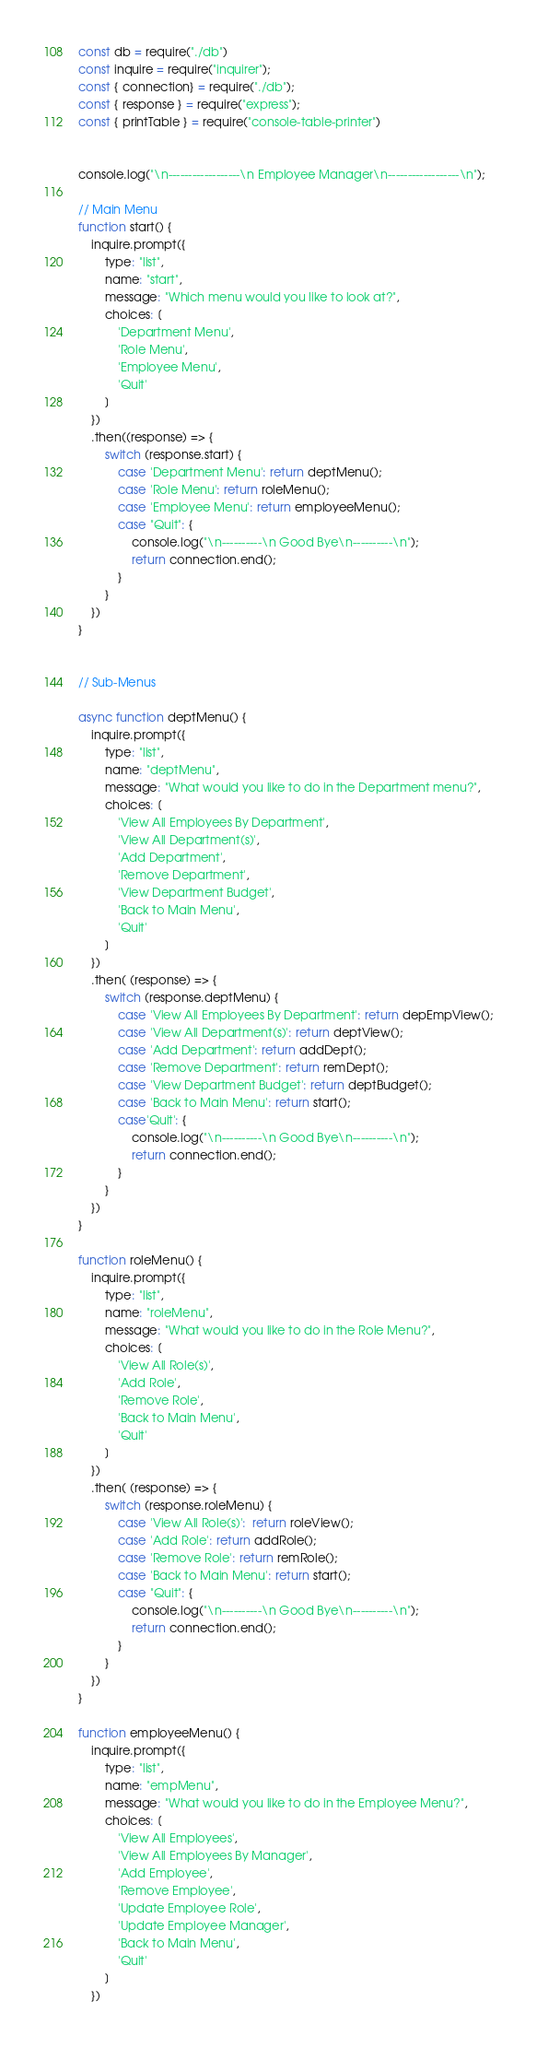<code> <loc_0><loc_0><loc_500><loc_500><_JavaScript_>const db = require("./db")
const inquire = require("inquirer");
const { connection} = require("./db");
const { response } = require("express");
const { printTable } = require("console-table-printer")


console.log("\n------------------\n Employee Manager\n------------------\n");

// Main Menu
function start() {
    inquire.prompt({
        type: "list",
        name: "start",
        message: "Which menu would you like to look at?",
        choices: [
            'Department Menu',
            'Role Menu',
            'Employee Menu',
            'Quit'
        ]
    })
    .then((response) => {
        switch (response.start) {
            case 'Department Menu': return deptMenu();
            case 'Role Menu': return roleMenu();
            case 'Employee Menu': return employeeMenu();
            case "Quit": {
                console.log("\n----------\n Good Bye\n----------\n");
                return connection.end();
            }
        }
    })
}


// Sub-Menus

async function deptMenu() {
    inquire.prompt({
        type: "list",
        name: "deptMenu",
        message: "What would you like to do in the Department menu?",
        choices: [
            'View All Employees By Department',
            'View All Department(s)',
            'Add Department', 
            'Remove Department',
            'View Department Budget',
            'Back to Main Menu',
            'Quit'
        ]
    })
    .then( (response) => {
        switch (response.deptMenu) {
            case 'View All Employees By Department': return depEmpView();
            case 'View All Department(s)': return deptView();
            case 'Add Department': return addDept();
            case 'Remove Department': return remDept();
            case 'View Department Budget': return deptBudget();
            case 'Back to Main Menu': return start();
            case'Quit': {
                console.log("\n----------\n Good Bye\n----------\n");
                return connection.end();
            }
        }
    })
}

function roleMenu() {
    inquire.prompt({
        type: "list",
        name: "roleMenu",
        message: "What would you like to do in the Role Menu?",
        choices: [
            'View All Role(s)',
            'Add Role', 
            'Remove Role',
            'Back to Main Menu',
            'Quit'
        ]
    })
    .then( (response) => {
        switch (response.roleMenu) {
            case 'View All Role(s)':  return roleView();
            case 'Add Role': return addRole();
            case 'Remove Role': return remRole();
            case 'Back to Main Menu': return start();
            case "Quit": {
                console.log("\n----------\n Good Bye\n----------\n");
                return connection.end();
            }
        }
    })
}

function employeeMenu() {
    inquire.prompt({
        type: "list",
        name: "empMenu",
        message: "What would you like to do in the Employee Menu?",
        choices: [
            'View All Employees',
            'View All Employees By Manager',
            'Add Employee', 
            'Remove Employee', 
            'Update Employee Role', 
            'Update Employee Manager',
            'Back to Main Menu',
            'Quit'
        ]
    })</code> 